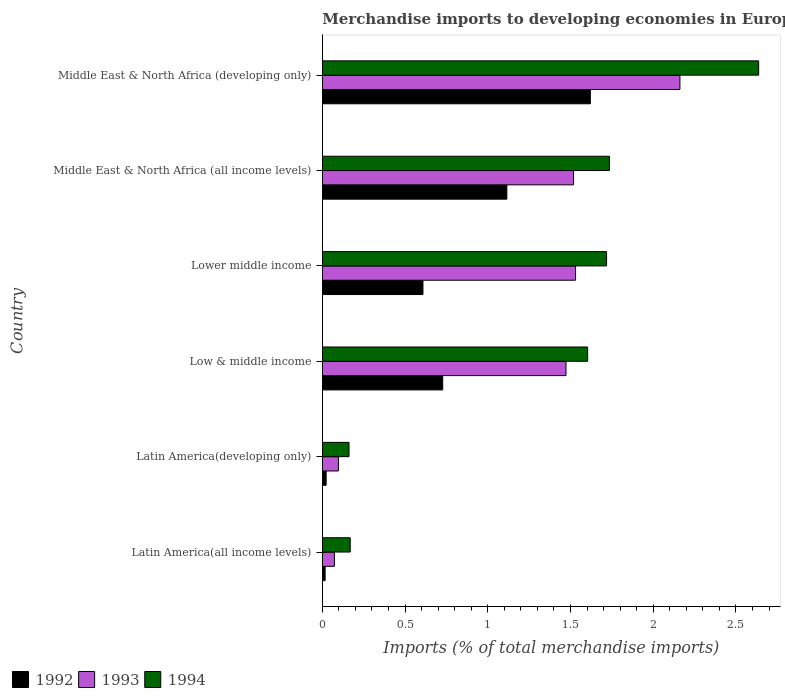Are the number of bars on each tick of the Y-axis equal?
Provide a succinct answer. Yes. What is the label of the 2nd group of bars from the top?
Keep it short and to the point. Middle East & North Africa (all income levels). In how many cases, is the number of bars for a given country not equal to the number of legend labels?
Provide a succinct answer. 0. What is the percentage total merchandise imports in 1994 in Low & middle income?
Provide a short and direct response. 1.6. Across all countries, what is the maximum percentage total merchandise imports in 1994?
Your answer should be very brief. 2.64. Across all countries, what is the minimum percentage total merchandise imports in 1992?
Provide a succinct answer. 0.02. In which country was the percentage total merchandise imports in 1993 maximum?
Provide a short and direct response. Middle East & North Africa (developing only). In which country was the percentage total merchandise imports in 1994 minimum?
Keep it short and to the point. Latin America(developing only). What is the total percentage total merchandise imports in 1993 in the graph?
Give a very brief answer. 6.85. What is the difference between the percentage total merchandise imports in 1993 in Latin America(all income levels) and that in Low & middle income?
Offer a terse response. -1.4. What is the difference between the percentage total merchandise imports in 1992 in Lower middle income and the percentage total merchandise imports in 1993 in Low & middle income?
Make the answer very short. -0.86. What is the average percentage total merchandise imports in 1993 per country?
Make the answer very short. 1.14. What is the difference between the percentage total merchandise imports in 1994 and percentage total merchandise imports in 1993 in Latin America(all income levels)?
Make the answer very short. 0.1. What is the ratio of the percentage total merchandise imports in 1993 in Latin America(developing only) to that in Middle East & North Africa (all income levels)?
Your answer should be compact. 0.06. Is the percentage total merchandise imports in 1994 in Latin America(developing only) less than that in Middle East & North Africa (developing only)?
Your response must be concise. Yes. What is the difference between the highest and the second highest percentage total merchandise imports in 1992?
Provide a short and direct response. 0.5. What is the difference between the highest and the lowest percentage total merchandise imports in 1993?
Make the answer very short. 2.09. Is it the case that in every country, the sum of the percentage total merchandise imports in 1994 and percentage total merchandise imports in 1992 is greater than the percentage total merchandise imports in 1993?
Keep it short and to the point. Yes. How many legend labels are there?
Your answer should be compact. 3. How are the legend labels stacked?
Provide a short and direct response. Horizontal. What is the title of the graph?
Keep it short and to the point. Merchandise imports to developing economies in Europe. What is the label or title of the X-axis?
Provide a succinct answer. Imports (% of total merchandise imports). What is the label or title of the Y-axis?
Keep it short and to the point. Country. What is the Imports (% of total merchandise imports) of 1992 in Latin America(all income levels)?
Offer a terse response. 0.02. What is the Imports (% of total merchandise imports) in 1993 in Latin America(all income levels)?
Your answer should be compact. 0.07. What is the Imports (% of total merchandise imports) in 1994 in Latin America(all income levels)?
Give a very brief answer. 0.17. What is the Imports (% of total merchandise imports) in 1992 in Latin America(developing only)?
Offer a terse response. 0.02. What is the Imports (% of total merchandise imports) in 1993 in Latin America(developing only)?
Give a very brief answer. 0.1. What is the Imports (% of total merchandise imports) in 1994 in Latin America(developing only)?
Provide a short and direct response. 0.16. What is the Imports (% of total merchandise imports) of 1992 in Low & middle income?
Keep it short and to the point. 0.73. What is the Imports (% of total merchandise imports) of 1993 in Low & middle income?
Offer a terse response. 1.47. What is the Imports (% of total merchandise imports) of 1994 in Low & middle income?
Provide a short and direct response. 1.6. What is the Imports (% of total merchandise imports) in 1992 in Lower middle income?
Your response must be concise. 0.61. What is the Imports (% of total merchandise imports) of 1993 in Lower middle income?
Your response must be concise. 1.53. What is the Imports (% of total merchandise imports) in 1994 in Lower middle income?
Your answer should be very brief. 1.72. What is the Imports (% of total merchandise imports) of 1992 in Middle East & North Africa (all income levels)?
Keep it short and to the point. 1.12. What is the Imports (% of total merchandise imports) of 1993 in Middle East & North Africa (all income levels)?
Give a very brief answer. 1.52. What is the Imports (% of total merchandise imports) in 1994 in Middle East & North Africa (all income levels)?
Ensure brevity in your answer.  1.74. What is the Imports (% of total merchandise imports) of 1992 in Middle East & North Africa (developing only)?
Ensure brevity in your answer.  1.62. What is the Imports (% of total merchandise imports) in 1993 in Middle East & North Africa (developing only)?
Your response must be concise. 2.16. What is the Imports (% of total merchandise imports) in 1994 in Middle East & North Africa (developing only)?
Offer a very short reply. 2.64. Across all countries, what is the maximum Imports (% of total merchandise imports) in 1992?
Make the answer very short. 1.62. Across all countries, what is the maximum Imports (% of total merchandise imports) of 1993?
Provide a succinct answer. 2.16. Across all countries, what is the maximum Imports (% of total merchandise imports) in 1994?
Provide a short and direct response. 2.64. Across all countries, what is the minimum Imports (% of total merchandise imports) of 1992?
Offer a very short reply. 0.02. Across all countries, what is the minimum Imports (% of total merchandise imports) of 1993?
Provide a short and direct response. 0.07. Across all countries, what is the minimum Imports (% of total merchandise imports) in 1994?
Provide a short and direct response. 0.16. What is the total Imports (% of total merchandise imports) of 1992 in the graph?
Provide a succinct answer. 4.11. What is the total Imports (% of total merchandise imports) in 1993 in the graph?
Keep it short and to the point. 6.85. What is the total Imports (% of total merchandise imports) of 1994 in the graph?
Your response must be concise. 8.02. What is the difference between the Imports (% of total merchandise imports) in 1992 in Latin America(all income levels) and that in Latin America(developing only)?
Make the answer very short. -0.01. What is the difference between the Imports (% of total merchandise imports) of 1993 in Latin America(all income levels) and that in Latin America(developing only)?
Keep it short and to the point. -0.02. What is the difference between the Imports (% of total merchandise imports) of 1994 in Latin America(all income levels) and that in Latin America(developing only)?
Provide a short and direct response. 0.01. What is the difference between the Imports (% of total merchandise imports) in 1992 in Latin America(all income levels) and that in Low & middle income?
Give a very brief answer. -0.71. What is the difference between the Imports (% of total merchandise imports) in 1993 in Latin America(all income levels) and that in Low & middle income?
Provide a succinct answer. -1.4. What is the difference between the Imports (% of total merchandise imports) in 1994 in Latin America(all income levels) and that in Low & middle income?
Make the answer very short. -1.44. What is the difference between the Imports (% of total merchandise imports) of 1992 in Latin America(all income levels) and that in Lower middle income?
Your answer should be compact. -0.59. What is the difference between the Imports (% of total merchandise imports) of 1993 in Latin America(all income levels) and that in Lower middle income?
Your answer should be compact. -1.46. What is the difference between the Imports (% of total merchandise imports) of 1994 in Latin America(all income levels) and that in Lower middle income?
Provide a succinct answer. -1.55. What is the difference between the Imports (% of total merchandise imports) of 1992 in Latin America(all income levels) and that in Middle East & North Africa (all income levels)?
Keep it short and to the point. -1.1. What is the difference between the Imports (% of total merchandise imports) in 1993 in Latin America(all income levels) and that in Middle East & North Africa (all income levels)?
Offer a very short reply. -1.45. What is the difference between the Imports (% of total merchandise imports) of 1994 in Latin America(all income levels) and that in Middle East & North Africa (all income levels)?
Your answer should be compact. -1.57. What is the difference between the Imports (% of total merchandise imports) in 1992 in Latin America(all income levels) and that in Middle East & North Africa (developing only)?
Provide a succinct answer. -1.6. What is the difference between the Imports (% of total merchandise imports) in 1993 in Latin America(all income levels) and that in Middle East & North Africa (developing only)?
Offer a terse response. -2.09. What is the difference between the Imports (% of total merchandise imports) in 1994 in Latin America(all income levels) and that in Middle East & North Africa (developing only)?
Provide a short and direct response. -2.47. What is the difference between the Imports (% of total merchandise imports) of 1992 in Latin America(developing only) and that in Low & middle income?
Provide a succinct answer. -0.7. What is the difference between the Imports (% of total merchandise imports) of 1993 in Latin America(developing only) and that in Low & middle income?
Offer a very short reply. -1.38. What is the difference between the Imports (% of total merchandise imports) in 1994 in Latin America(developing only) and that in Low & middle income?
Your response must be concise. -1.44. What is the difference between the Imports (% of total merchandise imports) of 1992 in Latin America(developing only) and that in Lower middle income?
Keep it short and to the point. -0.59. What is the difference between the Imports (% of total merchandise imports) of 1993 in Latin America(developing only) and that in Lower middle income?
Give a very brief answer. -1.43. What is the difference between the Imports (% of total merchandise imports) of 1994 in Latin America(developing only) and that in Lower middle income?
Your answer should be compact. -1.56. What is the difference between the Imports (% of total merchandise imports) in 1992 in Latin America(developing only) and that in Middle East & North Africa (all income levels)?
Offer a very short reply. -1.09. What is the difference between the Imports (% of total merchandise imports) in 1993 in Latin America(developing only) and that in Middle East & North Africa (all income levels)?
Your response must be concise. -1.42. What is the difference between the Imports (% of total merchandise imports) of 1994 in Latin America(developing only) and that in Middle East & North Africa (all income levels)?
Ensure brevity in your answer.  -1.57. What is the difference between the Imports (% of total merchandise imports) in 1992 in Latin America(developing only) and that in Middle East & North Africa (developing only)?
Provide a succinct answer. -1.6. What is the difference between the Imports (% of total merchandise imports) in 1993 in Latin America(developing only) and that in Middle East & North Africa (developing only)?
Your response must be concise. -2.06. What is the difference between the Imports (% of total merchandise imports) of 1994 in Latin America(developing only) and that in Middle East & North Africa (developing only)?
Offer a terse response. -2.48. What is the difference between the Imports (% of total merchandise imports) in 1992 in Low & middle income and that in Lower middle income?
Your answer should be very brief. 0.12. What is the difference between the Imports (% of total merchandise imports) in 1993 in Low & middle income and that in Lower middle income?
Your answer should be compact. -0.06. What is the difference between the Imports (% of total merchandise imports) in 1994 in Low & middle income and that in Lower middle income?
Provide a short and direct response. -0.11. What is the difference between the Imports (% of total merchandise imports) of 1992 in Low & middle income and that in Middle East & North Africa (all income levels)?
Your answer should be very brief. -0.39. What is the difference between the Imports (% of total merchandise imports) of 1993 in Low & middle income and that in Middle East & North Africa (all income levels)?
Make the answer very short. -0.05. What is the difference between the Imports (% of total merchandise imports) of 1994 in Low & middle income and that in Middle East & North Africa (all income levels)?
Make the answer very short. -0.13. What is the difference between the Imports (% of total merchandise imports) of 1992 in Low & middle income and that in Middle East & North Africa (developing only)?
Your answer should be very brief. -0.89. What is the difference between the Imports (% of total merchandise imports) in 1993 in Low & middle income and that in Middle East & North Africa (developing only)?
Provide a succinct answer. -0.69. What is the difference between the Imports (% of total merchandise imports) in 1994 in Low & middle income and that in Middle East & North Africa (developing only)?
Your response must be concise. -1.03. What is the difference between the Imports (% of total merchandise imports) in 1992 in Lower middle income and that in Middle East & North Africa (all income levels)?
Keep it short and to the point. -0.51. What is the difference between the Imports (% of total merchandise imports) in 1993 in Lower middle income and that in Middle East & North Africa (all income levels)?
Ensure brevity in your answer.  0.01. What is the difference between the Imports (% of total merchandise imports) in 1994 in Lower middle income and that in Middle East & North Africa (all income levels)?
Ensure brevity in your answer.  -0.02. What is the difference between the Imports (% of total merchandise imports) in 1992 in Lower middle income and that in Middle East & North Africa (developing only)?
Give a very brief answer. -1.01. What is the difference between the Imports (% of total merchandise imports) of 1993 in Lower middle income and that in Middle East & North Africa (developing only)?
Offer a terse response. -0.63. What is the difference between the Imports (% of total merchandise imports) in 1994 in Lower middle income and that in Middle East & North Africa (developing only)?
Provide a succinct answer. -0.92. What is the difference between the Imports (% of total merchandise imports) of 1992 in Middle East & North Africa (all income levels) and that in Middle East & North Africa (developing only)?
Your answer should be compact. -0.5. What is the difference between the Imports (% of total merchandise imports) in 1993 in Middle East & North Africa (all income levels) and that in Middle East & North Africa (developing only)?
Offer a very short reply. -0.64. What is the difference between the Imports (% of total merchandise imports) of 1994 in Middle East & North Africa (all income levels) and that in Middle East & North Africa (developing only)?
Make the answer very short. -0.9. What is the difference between the Imports (% of total merchandise imports) of 1992 in Latin America(all income levels) and the Imports (% of total merchandise imports) of 1993 in Latin America(developing only)?
Your answer should be very brief. -0.08. What is the difference between the Imports (% of total merchandise imports) in 1992 in Latin America(all income levels) and the Imports (% of total merchandise imports) in 1994 in Latin America(developing only)?
Provide a succinct answer. -0.14. What is the difference between the Imports (% of total merchandise imports) of 1993 in Latin America(all income levels) and the Imports (% of total merchandise imports) of 1994 in Latin America(developing only)?
Provide a succinct answer. -0.09. What is the difference between the Imports (% of total merchandise imports) of 1992 in Latin America(all income levels) and the Imports (% of total merchandise imports) of 1993 in Low & middle income?
Offer a very short reply. -1.46. What is the difference between the Imports (% of total merchandise imports) of 1992 in Latin America(all income levels) and the Imports (% of total merchandise imports) of 1994 in Low & middle income?
Your answer should be very brief. -1.59. What is the difference between the Imports (% of total merchandise imports) of 1993 in Latin America(all income levels) and the Imports (% of total merchandise imports) of 1994 in Low & middle income?
Your answer should be very brief. -1.53. What is the difference between the Imports (% of total merchandise imports) of 1992 in Latin America(all income levels) and the Imports (% of total merchandise imports) of 1993 in Lower middle income?
Offer a terse response. -1.51. What is the difference between the Imports (% of total merchandise imports) of 1992 in Latin America(all income levels) and the Imports (% of total merchandise imports) of 1994 in Lower middle income?
Your response must be concise. -1.7. What is the difference between the Imports (% of total merchandise imports) of 1993 in Latin America(all income levels) and the Imports (% of total merchandise imports) of 1994 in Lower middle income?
Offer a very short reply. -1.65. What is the difference between the Imports (% of total merchandise imports) of 1992 in Latin America(all income levels) and the Imports (% of total merchandise imports) of 1993 in Middle East & North Africa (all income levels)?
Your answer should be compact. -1.5. What is the difference between the Imports (% of total merchandise imports) of 1992 in Latin America(all income levels) and the Imports (% of total merchandise imports) of 1994 in Middle East & North Africa (all income levels)?
Provide a succinct answer. -1.72. What is the difference between the Imports (% of total merchandise imports) in 1993 in Latin America(all income levels) and the Imports (% of total merchandise imports) in 1994 in Middle East & North Africa (all income levels)?
Your answer should be compact. -1.66. What is the difference between the Imports (% of total merchandise imports) of 1992 in Latin America(all income levels) and the Imports (% of total merchandise imports) of 1993 in Middle East & North Africa (developing only)?
Your answer should be very brief. -2.14. What is the difference between the Imports (% of total merchandise imports) in 1992 in Latin America(all income levels) and the Imports (% of total merchandise imports) in 1994 in Middle East & North Africa (developing only)?
Ensure brevity in your answer.  -2.62. What is the difference between the Imports (% of total merchandise imports) of 1993 in Latin America(all income levels) and the Imports (% of total merchandise imports) of 1994 in Middle East & North Africa (developing only)?
Offer a terse response. -2.56. What is the difference between the Imports (% of total merchandise imports) of 1992 in Latin America(developing only) and the Imports (% of total merchandise imports) of 1993 in Low & middle income?
Your answer should be compact. -1.45. What is the difference between the Imports (% of total merchandise imports) of 1992 in Latin America(developing only) and the Imports (% of total merchandise imports) of 1994 in Low & middle income?
Your answer should be very brief. -1.58. What is the difference between the Imports (% of total merchandise imports) of 1993 in Latin America(developing only) and the Imports (% of total merchandise imports) of 1994 in Low & middle income?
Offer a very short reply. -1.51. What is the difference between the Imports (% of total merchandise imports) in 1992 in Latin America(developing only) and the Imports (% of total merchandise imports) in 1993 in Lower middle income?
Provide a succinct answer. -1.51. What is the difference between the Imports (% of total merchandise imports) in 1992 in Latin America(developing only) and the Imports (% of total merchandise imports) in 1994 in Lower middle income?
Give a very brief answer. -1.7. What is the difference between the Imports (% of total merchandise imports) in 1993 in Latin America(developing only) and the Imports (% of total merchandise imports) in 1994 in Lower middle income?
Give a very brief answer. -1.62. What is the difference between the Imports (% of total merchandise imports) in 1992 in Latin America(developing only) and the Imports (% of total merchandise imports) in 1993 in Middle East & North Africa (all income levels)?
Keep it short and to the point. -1.5. What is the difference between the Imports (% of total merchandise imports) in 1992 in Latin America(developing only) and the Imports (% of total merchandise imports) in 1994 in Middle East & North Africa (all income levels)?
Provide a short and direct response. -1.71. What is the difference between the Imports (% of total merchandise imports) in 1993 in Latin America(developing only) and the Imports (% of total merchandise imports) in 1994 in Middle East & North Africa (all income levels)?
Keep it short and to the point. -1.64. What is the difference between the Imports (% of total merchandise imports) in 1992 in Latin America(developing only) and the Imports (% of total merchandise imports) in 1993 in Middle East & North Africa (developing only)?
Offer a terse response. -2.14. What is the difference between the Imports (% of total merchandise imports) in 1992 in Latin America(developing only) and the Imports (% of total merchandise imports) in 1994 in Middle East & North Africa (developing only)?
Ensure brevity in your answer.  -2.61. What is the difference between the Imports (% of total merchandise imports) of 1993 in Latin America(developing only) and the Imports (% of total merchandise imports) of 1994 in Middle East & North Africa (developing only)?
Provide a short and direct response. -2.54. What is the difference between the Imports (% of total merchandise imports) of 1992 in Low & middle income and the Imports (% of total merchandise imports) of 1993 in Lower middle income?
Your response must be concise. -0.8. What is the difference between the Imports (% of total merchandise imports) of 1992 in Low & middle income and the Imports (% of total merchandise imports) of 1994 in Lower middle income?
Provide a succinct answer. -0.99. What is the difference between the Imports (% of total merchandise imports) of 1993 in Low & middle income and the Imports (% of total merchandise imports) of 1994 in Lower middle income?
Make the answer very short. -0.25. What is the difference between the Imports (% of total merchandise imports) in 1992 in Low & middle income and the Imports (% of total merchandise imports) in 1993 in Middle East & North Africa (all income levels)?
Your response must be concise. -0.79. What is the difference between the Imports (% of total merchandise imports) in 1992 in Low & middle income and the Imports (% of total merchandise imports) in 1994 in Middle East & North Africa (all income levels)?
Offer a terse response. -1.01. What is the difference between the Imports (% of total merchandise imports) in 1993 in Low & middle income and the Imports (% of total merchandise imports) in 1994 in Middle East & North Africa (all income levels)?
Offer a terse response. -0.26. What is the difference between the Imports (% of total merchandise imports) in 1992 in Low & middle income and the Imports (% of total merchandise imports) in 1993 in Middle East & North Africa (developing only)?
Ensure brevity in your answer.  -1.43. What is the difference between the Imports (% of total merchandise imports) in 1992 in Low & middle income and the Imports (% of total merchandise imports) in 1994 in Middle East & North Africa (developing only)?
Make the answer very short. -1.91. What is the difference between the Imports (% of total merchandise imports) in 1993 in Low & middle income and the Imports (% of total merchandise imports) in 1994 in Middle East & North Africa (developing only)?
Offer a terse response. -1.16. What is the difference between the Imports (% of total merchandise imports) of 1992 in Lower middle income and the Imports (% of total merchandise imports) of 1993 in Middle East & North Africa (all income levels)?
Offer a very short reply. -0.91. What is the difference between the Imports (% of total merchandise imports) in 1992 in Lower middle income and the Imports (% of total merchandise imports) in 1994 in Middle East & North Africa (all income levels)?
Provide a short and direct response. -1.13. What is the difference between the Imports (% of total merchandise imports) in 1993 in Lower middle income and the Imports (% of total merchandise imports) in 1994 in Middle East & North Africa (all income levels)?
Offer a terse response. -0.2. What is the difference between the Imports (% of total merchandise imports) in 1992 in Lower middle income and the Imports (% of total merchandise imports) in 1993 in Middle East & North Africa (developing only)?
Offer a very short reply. -1.55. What is the difference between the Imports (% of total merchandise imports) of 1992 in Lower middle income and the Imports (% of total merchandise imports) of 1994 in Middle East & North Africa (developing only)?
Keep it short and to the point. -2.03. What is the difference between the Imports (% of total merchandise imports) of 1993 in Lower middle income and the Imports (% of total merchandise imports) of 1994 in Middle East & North Africa (developing only)?
Offer a terse response. -1.11. What is the difference between the Imports (% of total merchandise imports) of 1992 in Middle East & North Africa (all income levels) and the Imports (% of total merchandise imports) of 1993 in Middle East & North Africa (developing only)?
Give a very brief answer. -1.05. What is the difference between the Imports (% of total merchandise imports) in 1992 in Middle East & North Africa (all income levels) and the Imports (% of total merchandise imports) in 1994 in Middle East & North Africa (developing only)?
Keep it short and to the point. -1.52. What is the difference between the Imports (% of total merchandise imports) of 1993 in Middle East & North Africa (all income levels) and the Imports (% of total merchandise imports) of 1994 in Middle East & North Africa (developing only)?
Your answer should be compact. -1.12. What is the average Imports (% of total merchandise imports) of 1992 per country?
Give a very brief answer. 0.69. What is the average Imports (% of total merchandise imports) in 1993 per country?
Your response must be concise. 1.14. What is the average Imports (% of total merchandise imports) of 1994 per country?
Your answer should be compact. 1.34. What is the difference between the Imports (% of total merchandise imports) in 1992 and Imports (% of total merchandise imports) in 1993 in Latin America(all income levels)?
Ensure brevity in your answer.  -0.06. What is the difference between the Imports (% of total merchandise imports) of 1992 and Imports (% of total merchandise imports) of 1994 in Latin America(all income levels)?
Offer a terse response. -0.15. What is the difference between the Imports (% of total merchandise imports) in 1993 and Imports (% of total merchandise imports) in 1994 in Latin America(all income levels)?
Offer a very short reply. -0.1. What is the difference between the Imports (% of total merchandise imports) in 1992 and Imports (% of total merchandise imports) in 1993 in Latin America(developing only)?
Provide a succinct answer. -0.07. What is the difference between the Imports (% of total merchandise imports) in 1992 and Imports (% of total merchandise imports) in 1994 in Latin America(developing only)?
Your answer should be compact. -0.14. What is the difference between the Imports (% of total merchandise imports) of 1993 and Imports (% of total merchandise imports) of 1994 in Latin America(developing only)?
Make the answer very short. -0.06. What is the difference between the Imports (% of total merchandise imports) of 1992 and Imports (% of total merchandise imports) of 1993 in Low & middle income?
Offer a very short reply. -0.74. What is the difference between the Imports (% of total merchandise imports) in 1992 and Imports (% of total merchandise imports) in 1994 in Low & middle income?
Provide a succinct answer. -0.88. What is the difference between the Imports (% of total merchandise imports) in 1993 and Imports (% of total merchandise imports) in 1994 in Low & middle income?
Your answer should be compact. -0.13. What is the difference between the Imports (% of total merchandise imports) of 1992 and Imports (% of total merchandise imports) of 1993 in Lower middle income?
Provide a succinct answer. -0.92. What is the difference between the Imports (% of total merchandise imports) in 1992 and Imports (% of total merchandise imports) in 1994 in Lower middle income?
Give a very brief answer. -1.11. What is the difference between the Imports (% of total merchandise imports) of 1993 and Imports (% of total merchandise imports) of 1994 in Lower middle income?
Provide a short and direct response. -0.19. What is the difference between the Imports (% of total merchandise imports) in 1992 and Imports (% of total merchandise imports) in 1993 in Middle East & North Africa (all income levels)?
Provide a succinct answer. -0.4. What is the difference between the Imports (% of total merchandise imports) of 1992 and Imports (% of total merchandise imports) of 1994 in Middle East & North Africa (all income levels)?
Your response must be concise. -0.62. What is the difference between the Imports (% of total merchandise imports) in 1993 and Imports (% of total merchandise imports) in 1994 in Middle East & North Africa (all income levels)?
Give a very brief answer. -0.22. What is the difference between the Imports (% of total merchandise imports) of 1992 and Imports (% of total merchandise imports) of 1993 in Middle East & North Africa (developing only)?
Provide a short and direct response. -0.54. What is the difference between the Imports (% of total merchandise imports) of 1992 and Imports (% of total merchandise imports) of 1994 in Middle East & North Africa (developing only)?
Give a very brief answer. -1.02. What is the difference between the Imports (% of total merchandise imports) of 1993 and Imports (% of total merchandise imports) of 1994 in Middle East & North Africa (developing only)?
Offer a terse response. -0.48. What is the ratio of the Imports (% of total merchandise imports) in 1992 in Latin America(all income levels) to that in Latin America(developing only)?
Your answer should be very brief. 0.73. What is the ratio of the Imports (% of total merchandise imports) of 1993 in Latin America(all income levels) to that in Latin America(developing only)?
Your answer should be compact. 0.75. What is the ratio of the Imports (% of total merchandise imports) in 1994 in Latin America(all income levels) to that in Latin America(developing only)?
Make the answer very short. 1.04. What is the ratio of the Imports (% of total merchandise imports) in 1992 in Latin America(all income levels) to that in Low & middle income?
Your answer should be very brief. 0.02. What is the ratio of the Imports (% of total merchandise imports) in 1993 in Latin America(all income levels) to that in Low & middle income?
Provide a short and direct response. 0.05. What is the ratio of the Imports (% of total merchandise imports) of 1994 in Latin America(all income levels) to that in Low & middle income?
Your response must be concise. 0.11. What is the ratio of the Imports (% of total merchandise imports) in 1992 in Latin America(all income levels) to that in Lower middle income?
Offer a terse response. 0.03. What is the ratio of the Imports (% of total merchandise imports) in 1993 in Latin America(all income levels) to that in Lower middle income?
Give a very brief answer. 0.05. What is the ratio of the Imports (% of total merchandise imports) of 1994 in Latin America(all income levels) to that in Lower middle income?
Your response must be concise. 0.1. What is the ratio of the Imports (% of total merchandise imports) in 1992 in Latin America(all income levels) to that in Middle East & North Africa (all income levels)?
Your answer should be compact. 0.02. What is the ratio of the Imports (% of total merchandise imports) in 1993 in Latin America(all income levels) to that in Middle East & North Africa (all income levels)?
Offer a very short reply. 0.05. What is the ratio of the Imports (% of total merchandise imports) of 1994 in Latin America(all income levels) to that in Middle East & North Africa (all income levels)?
Your answer should be compact. 0.1. What is the ratio of the Imports (% of total merchandise imports) in 1992 in Latin America(all income levels) to that in Middle East & North Africa (developing only)?
Keep it short and to the point. 0.01. What is the ratio of the Imports (% of total merchandise imports) in 1993 in Latin America(all income levels) to that in Middle East & North Africa (developing only)?
Keep it short and to the point. 0.03. What is the ratio of the Imports (% of total merchandise imports) in 1994 in Latin America(all income levels) to that in Middle East & North Africa (developing only)?
Make the answer very short. 0.06. What is the ratio of the Imports (% of total merchandise imports) in 1992 in Latin America(developing only) to that in Low & middle income?
Ensure brevity in your answer.  0.03. What is the ratio of the Imports (% of total merchandise imports) of 1993 in Latin America(developing only) to that in Low & middle income?
Make the answer very short. 0.07. What is the ratio of the Imports (% of total merchandise imports) in 1994 in Latin America(developing only) to that in Low & middle income?
Give a very brief answer. 0.1. What is the ratio of the Imports (% of total merchandise imports) of 1992 in Latin America(developing only) to that in Lower middle income?
Your answer should be very brief. 0.04. What is the ratio of the Imports (% of total merchandise imports) of 1993 in Latin America(developing only) to that in Lower middle income?
Offer a terse response. 0.06. What is the ratio of the Imports (% of total merchandise imports) in 1994 in Latin America(developing only) to that in Lower middle income?
Provide a succinct answer. 0.09. What is the ratio of the Imports (% of total merchandise imports) in 1992 in Latin America(developing only) to that in Middle East & North Africa (all income levels)?
Provide a succinct answer. 0.02. What is the ratio of the Imports (% of total merchandise imports) in 1993 in Latin America(developing only) to that in Middle East & North Africa (all income levels)?
Ensure brevity in your answer.  0.06. What is the ratio of the Imports (% of total merchandise imports) of 1994 in Latin America(developing only) to that in Middle East & North Africa (all income levels)?
Ensure brevity in your answer.  0.09. What is the ratio of the Imports (% of total merchandise imports) in 1992 in Latin America(developing only) to that in Middle East & North Africa (developing only)?
Ensure brevity in your answer.  0.01. What is the ratio of the Imports (% of total merchandise imports) in 1993 in Latin America(developing only) to that in Middle East & North Africa (developing only)?
Ensure brevity in your answer.  0.04. What is the ratio of the Imports (% of total merchandise imports) of 1994 in Latin America(developing only) to that in Middle East & North Africa (developing only)?
Offer a terse response. 0.06. What is the ratio of the Imports (% of total merchandise imports) in 1992 in Low & middle income to that in Lower middle income?
Make the answer very short. 1.2. What is the ratio of the Imports (% of total merchandise imports) in 1993 in Low & middle income to that in Lower middle income?
Your answer should be very brief. 0.96. What is the ratio of the Imports (% of total merchandise imports) in 1994 in Low & middle income to that in Lower middle income?
Offer a very short reply. 0.93. What is the ratio of the Imports (% of total merchandise imports) in 1992 in Low & middle income to that in Middle East & North Africa (all income levels)?
Ensure brevity in your answer.  0.65. What is the ratio of the Imports (% of total merchandise imports) in 1993 in Low & middle income to that in Middle East & North Africa (all income levels)?
Your response must be concise. 0.97. What is the ratio of the Imports (% of total merchandise imports) in 1994 in Low & middle income to that in Middle East & North Africa (all income levels)?
Offer a terse response. 0.92. What is the ratio of the Imports (% of total merchandise imports) in 1992 in Low & middle income to that in Middle East & North Africa (developing only)?
Ensure brevity in your answer.  0.45. What is the ratio of the Imports (% of total merchandise imports) in 1993 in Low & middle income to that in Middle East & North Africa (developing only)?
Make the answer very short. 0.68. What is the ratio of the Imports (% of total merchandise imports) in 1994 in Low & middle income to that in Middle East & North Africa (developing only)?
Provide a succinct answer. 0.61. What is the ratio of the Imports (% of total merchandise imports) of 1992 in Lower middle income to that in Middle East & North Africa (all income levels)?
Ensure brevity in your answer.  0.55. What is the ratio of the Imports (% of total merchandise imports) of 1993 in Lower middle income to that in Middle East & North Africa (all income levels)?
Your response must be concise. 1.01. What is the ratio of the Imports (% of total merchandise imports) of 1994 in Lower middle income to that in Middle East & North Africa (all income levels)?
Offer a very short reply. 0.99. What is the ratio of the Imports (% of total merchandise imports) of 1992 in Lower middle income to that in Middle East & North Africa (developing only)?
Ensure brevity in your answer.  0.38. What is the ratio of the Imports (% of total merchandise imports) of 1993 in Lower middle income to that in Middle East & North Africa (developing only)?
Your answer should be very brief. 0.71. What is the ratio of the Imports (% of total merchandise imports) in 1994 in Lower middle income to that in Middle East & North Africa (developing only)?
Ensure brevity in your answer.  0.65. What is the ratio of the Imports (% of total merchandise imports) in 1992 in Middle East & North Africa (all income levels) to that in Middle East & North Africa (developing only)?
Your response must be concise. 0.69. What is the ratio of the Imports (% of total merchandise imports) of 1993 in Middle East & North Africa (all income levels) to that in Middle East & North Africa (developing only)?
Offer a terse response. 0.7. What is the ratio of the Imports (% of total merchandise imports) of 1994 in Middle East & North Africa (all income levels) to that in Middle East & North Africa (developing only)?
Keep it short and to the point. 0.66. What is the difference between the highest and the second highest Imports (% of total merchandise imports) in 1992?
Your answer should be compact. 0.5. What is the difference between the highest and the second highest Imports (% of total merchandise imports) of 1993?
Your response must be concise. 0.63. What is the difference between the highest and the second highest Imports (% of total merchandise imports) in 1994?
Offer a very short reply. 0.9. What is the difference between the highest and the lowest Imports (% of total merchandise imports) of 1992?
Your answer should be very brief. 1.6. What is the difference between the highest and the lowest Imports (% of total merchandise imports) of 1993?
Keep it short and to the point. 2.09. What is the difference between the highest and the lowest Imports (% of total merchandise imports) of 1994?
Your answer should be very brief. 2.48. 